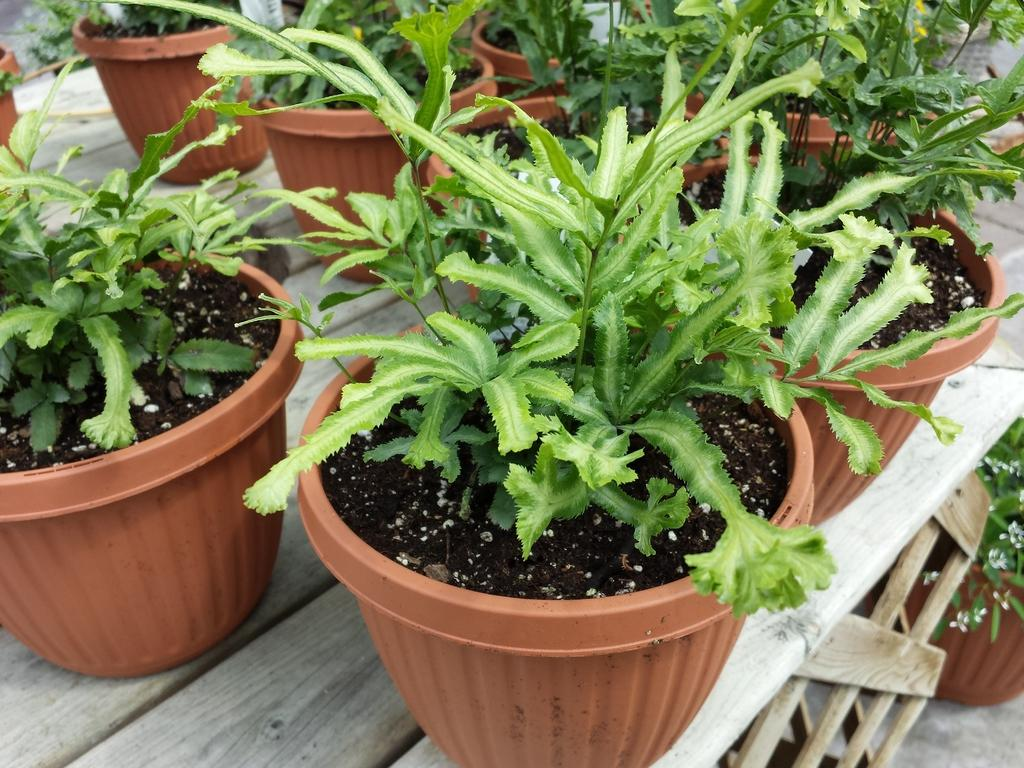What is the main subject in the center of the image? There are plant pots in the center of the image. What is the surface on which the plant pots are placed? The plant pots are on a wooden table. Are there any other plant pots visible in the image? Yes, there is another plant pot on the right side of the image. What type of noise can be heard coming from the plant pots in the image? There is no noise coming from the plant pots in the image. Are there any pigs present in the image? No, there are no pigs present in the image. 